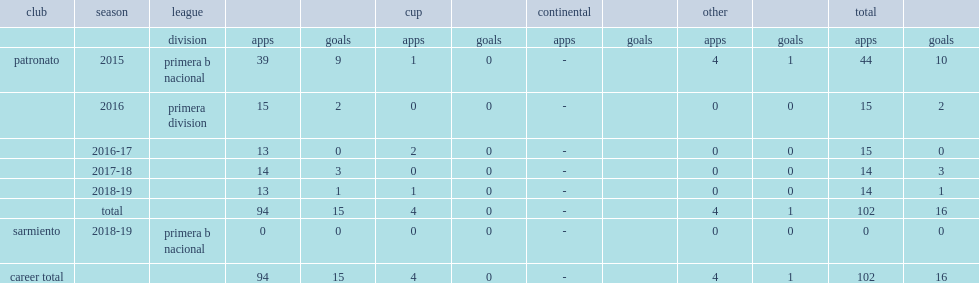Which club did garrido join in primera b nacional? Patronato. 